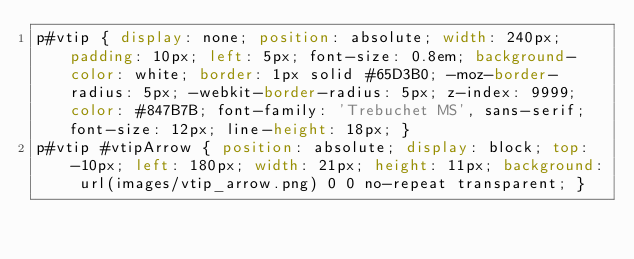Convert code to text. <code><loc_0><loc_0><loc_500><loc_500><_CSS_>p#vtip { display: none; position: absolute; width: 240px; padding: 10px; left: 5px; font-size: 0.8em; background-color: white; border: 1px solid #65D3B0; -moz-border-radius: 5px; -webkit-border-radius: 5px; z-index: 9999; color: #847B7B; font-family: 'Trebuchet MS', sans-serif; font-size: 12px; line-height: 18px; }
p#vtip #vtipArrow { position: absolute; display: block; top: -10px; left: 180px; width: 21px; height: 11px; background: url(images/vtip_arrow.png) 0 0 no-repeat transparent; }</code> 